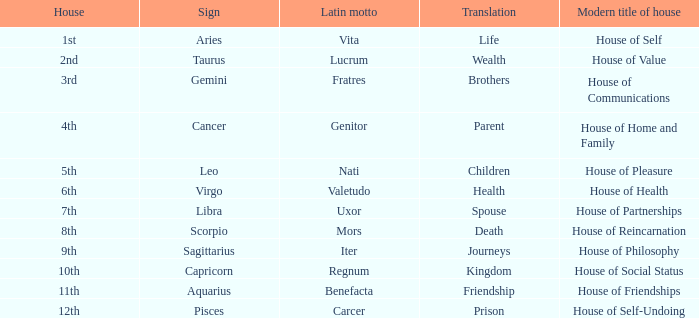Which sign has a modern house title of House of Partnerships? Libra. 